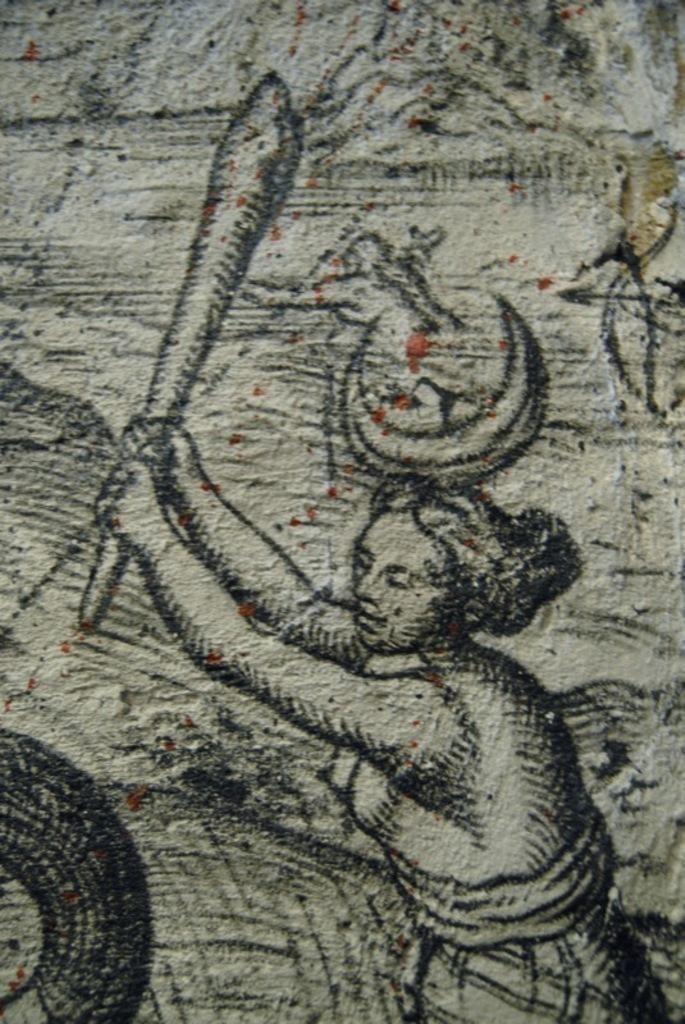What is present on the wall in the image? There is a woman painting on the wall in the image. What is the woman doing in the image? The woman is painting on the wall. How many cacti are present on the wall in the image? There are no cacti present on the wall in the image; it only shows a woman painting. 